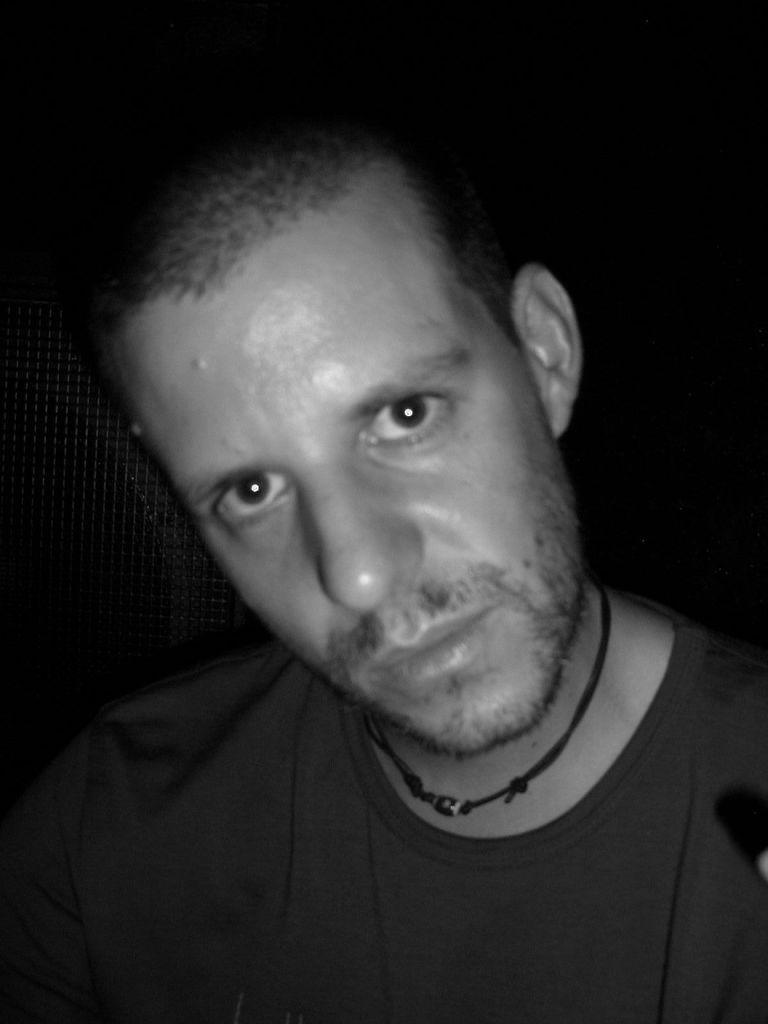Can you describe this image briefly? In this image we can see black and white picture of a person. 